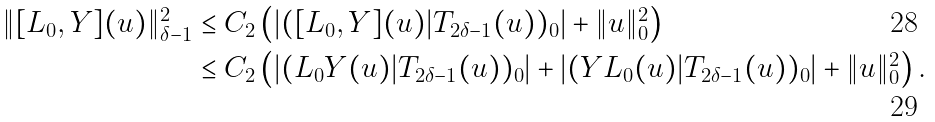Convert formula to latex. <formula><loc_0><loc_0><loc_500><loc_500>\| [ L _ { 0 } , Y ] ( u ) \| _ { \delta - 1 } ^ { 2 } & \leq C _ { 2 } \left ( | ( [ L _ { 0 } , Y ] ( u ) | T _ { 2 \delta - 1 } ( u ) ) _ { 0 } | + \| u \| _ { 0 } ^ { 2 } \right ) \\ & \leq C _ { 2 } \left ( | ( L _ { 0 } Y ( u ) | T _ { 2 \delta - 1 } ( u ) ) _ { 0 } | + | ( Y L _ { 0 } ( u ) | T _ { 2 \delta - 1 } ( u ) ) _ { 0 } | + \| u \| _ { 0 } ^ { 2 } \right ) .</formula> 